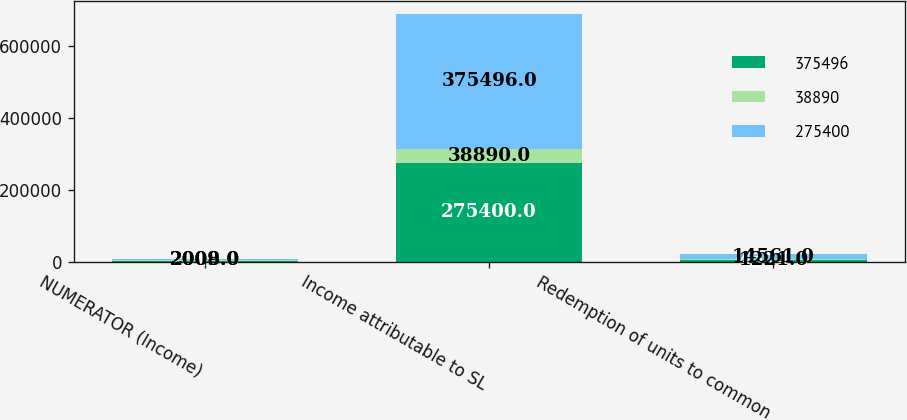Convert chart to OTSL. <chart><loc_0><loc_0><loc_500><loc_500><stacked_bar_chart><ecel><fcel>NUMERATOR (Income)<fcel>Income attributable to SL<fcel>Redemption of units to common<nl><fcel>375496<fcel>2010<fcel>275400<fcel>4574<nl><fcel>38890<fcel>2009<fcel>38890<fcel>1221<nl><fcel>275400<fcel>2008<fcel>375496<fcel>14561<nl></chart> 